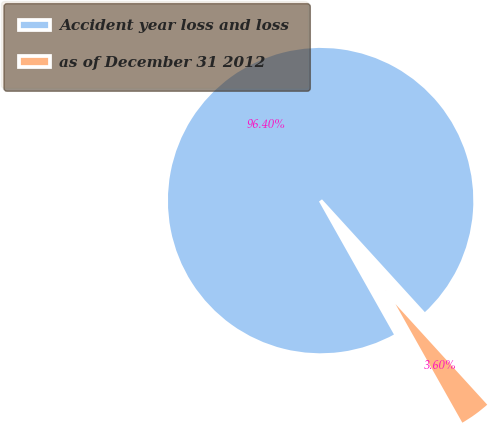Convert chart. <chart><loc_0><loc_0><loc_500><loc_500><pie_chart><fcel>Accident year loss and loss<fcel>as of December 31 2012<nl><fcel>96.4%<fcel>3.6%<nl></chart> 